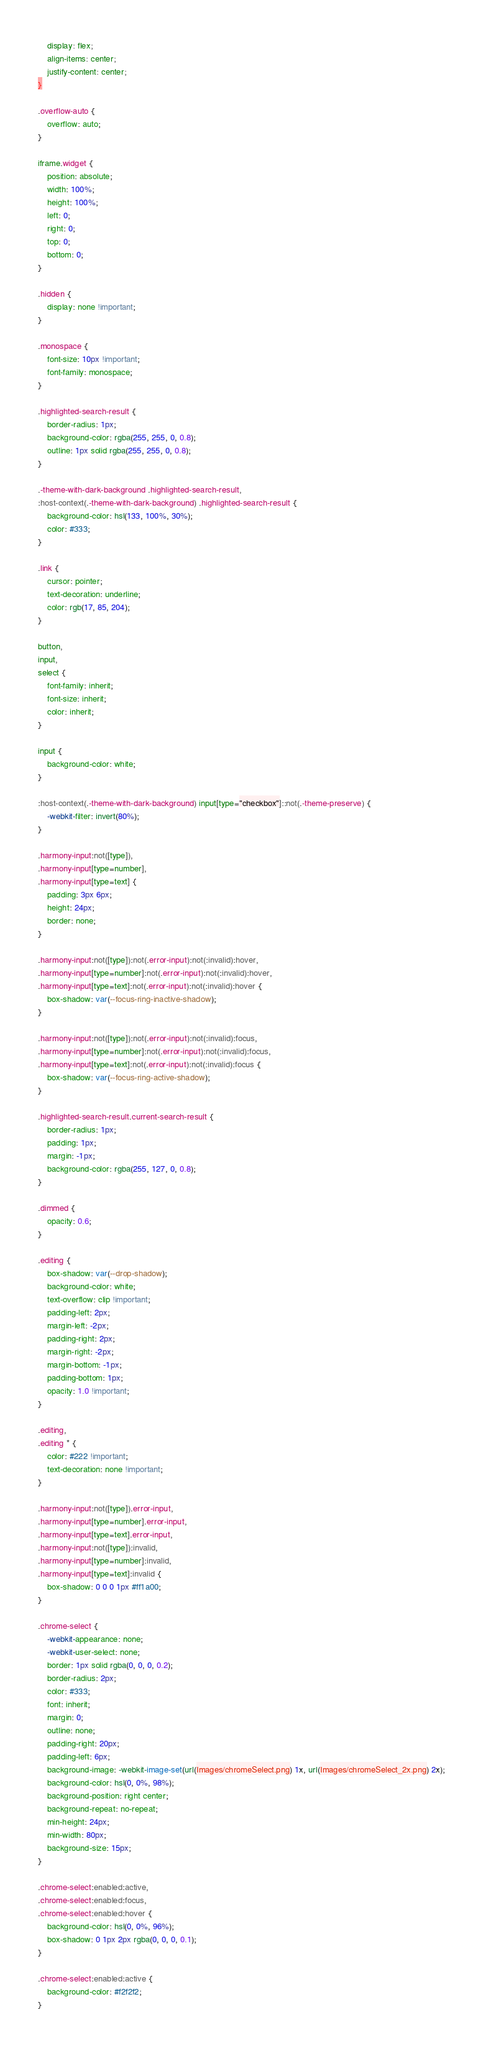<code> <loc_0><loc_0><loc_500><loc_500><_CSS_>    display: flex;
    align-items: center;
    justify-content: center;
}

.overflow-auto {
    overflow: auto;
}

iframe.widget {
    position: absolute;
    width: 100%;
    height: 100%;
    left: 0;
    right: 0;
    top: 0;
    bottom: 0;
}

.hidden {
    display: none !important;
}

.monospace {
    font-size: 10px !important;
    font-family: monospace;
}

.highlighted-search-result {
    border-radius: 1px;
    background-color: rgba(255, 255, 0, 0.8);
    outline: 1px solid rgba(255, 255, 0, 0.8);
}

.-theme-with-dark-background .highlighted-search-result,
:host-context(.-theme-with-dark-background) .highlighted-search-result {
    background-color: hsl(133, 100%, 30%);
    color: #333;
}

.link {
    cursor: pointer;
    text-decoration: underline;
    color: rgb(17, 85, 204);
}

button,
input,
select {
    font-family: inherit;
    font-size: inherit;
    color: inherit;
}

input {
    background-color: white;
}

:host-context(.-theme-with-dark-background) input[type="checkbox"]::not(.-theme-preserve) {
    -webkit-filter: invert(80%);
}

.harmony-input:not([type]),
.harmony-input[type=number],
.harmony-input[type=text] {
    padding: 3px 6px;
    height: 24px;
    border: none;
}

.harmony-input:not([type]):not(.error-input):not(:invalid):hover,
.harmony-input[type=number]:not(.error-input):not(:invalid):hover,
.harmony-input[type=text]:not(.error-input):not(:invalid):hover {
    box-shadow: var(--focus-ring-inactive-shadow);
}

.harmony-input:not([type]):not(.error-input):not(:invalid):focus,
.harmony-input[type=number]:not(.error-input):not(:invalid):focus,
.harmony-input[type=text]:not(.error-input):not(:invalid):focus {
    box-shadow: var(--focus-ring-active-shadow);
}

.highlighted-search-result.current-search-result {
    border-radius: 1px;
    padding: 1px;
    margin: -1px;
    background-color: rgba(255, 127, 0, 0.8);
}

.dimmed {
    opacity: 0.6;
}

.editing {
    box-shadow: var(--drop-shadow);
    background-color: white;
    text-overflow: clip !important;
    padding-left: 2px;
    margin-left: -2px;
    padding-right: 2px;
    margin-right: -2px;
    margin-bottom: -1px;
    padding-bottom: 1px;
    opacity: 1.0 !important;
}

.editing,
.editing * {
    color: #222 !important;
    text-decoration: none !important;
}

.harmony-input:not([type]).error-input,
.harmony-input[type=number].error-input,
.harmony-input[type=text].error-input,
.harmony-input:not([type]):invalid,
.harmony-input[type=number]:invalid,
.harmony-input[type=text]:invalid {
    box-shadow: 0 0 0 1px #ff1a00;
}

.chrome-select {
    -webkit-appearance: none;
    -webkit-user-select: none;
    border: 1px solid rgba(0, 0, 0, 0.2);
    border-radius: 2px;
    color: #333;
    font: inherit;
    margin: 0;
    outline: none;
    padding-right: 20px;
    padding-left: 6px;
    background-image: -webkit-image-set(url(Images/chromeSelect.png) 1x, url(Images/chromeSelect_2x.png) 2x);
    background-color: hsl(0, 0%, 98%);
    background-position: right center;
    background-repeat: no-repeat;
    min-height: 24px;
    min-width: 80px;
    background-size: 15px;
}

.chrome-select:enabled:active,
.chrome-select:enabled:focus,
.chrome-select:enabled:hover {
    background-color: hsl(0, 0%, 96%);
    box-shadow: 0 1px 2px rgba(0, 0, 0, 0.1);
}

.chrome-select:enabled:active {
    background-color: #f2f2f2;
}
</code> 